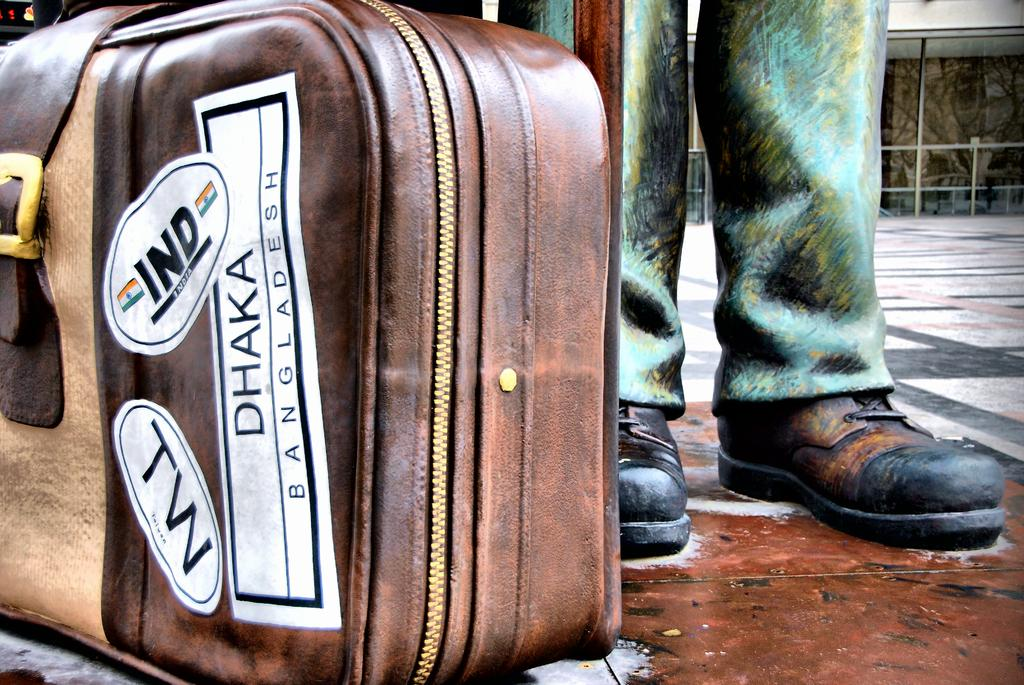What object can be seen on the left side of the image? There is a suitcase on the left side of the image. Where is the person located in the image? The person is in the top right side of the image. What is behind the person in the image? There is a fencing behind the person. How many bees can be seen flying around the person in the image? There are no bees present in the image. What type of field is visible in the background of the image? There is no field visible in the background of the image. 